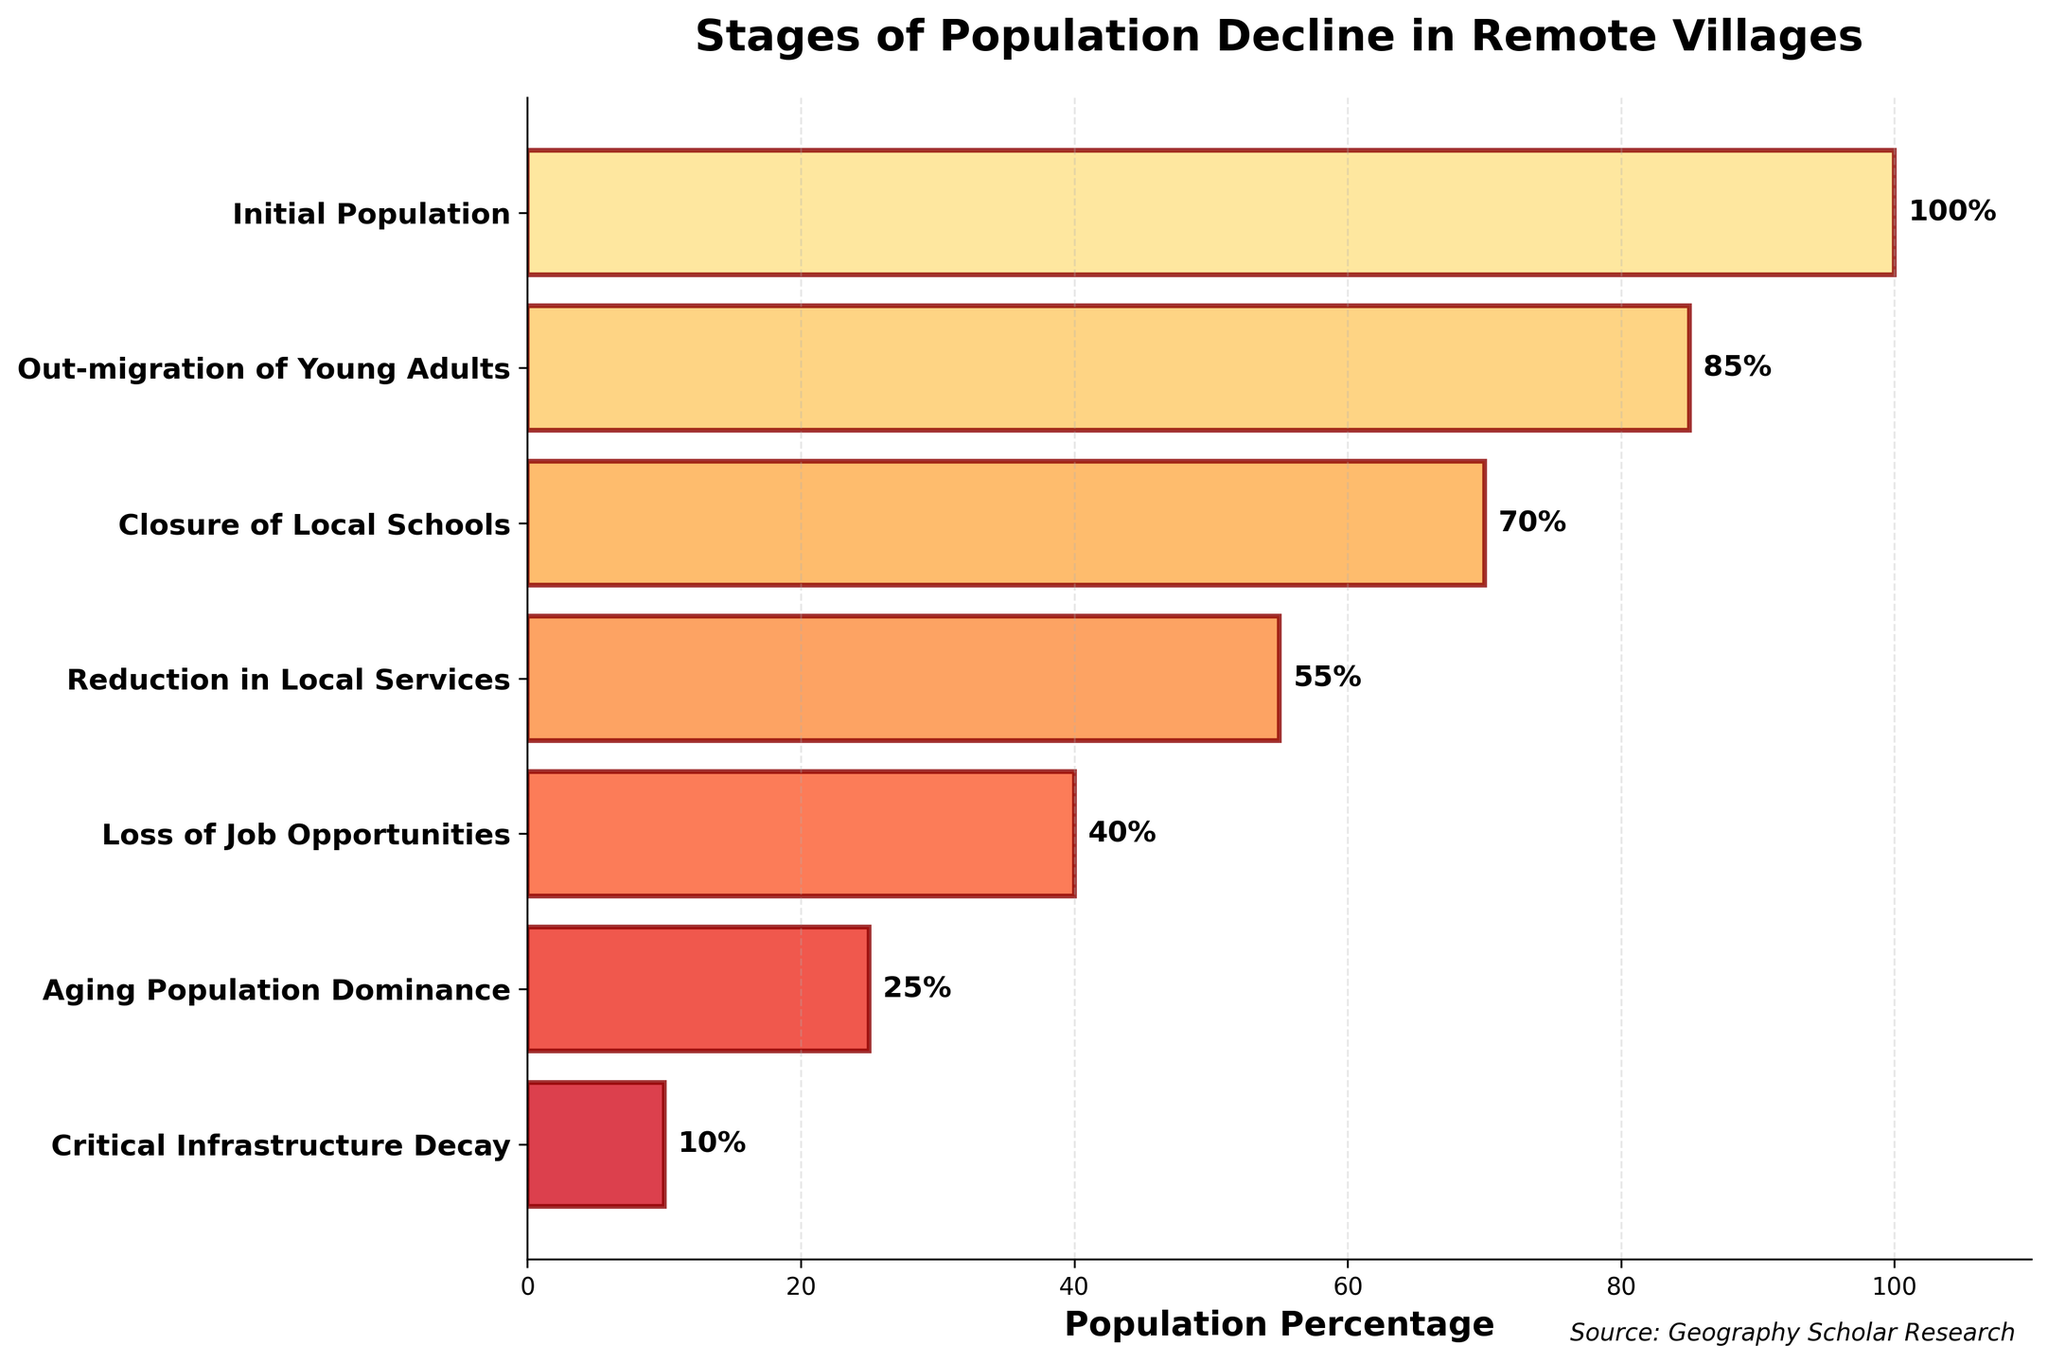What's the title of the figure? The title is usually displayed at the top of a figure and helps to provide context about the data being presented.
Answer: Stages of Population Decline in Remote Villages What's the population percentage after the "Out-migration of Young Adults" stage? The population percentage for this stage is shown directly to the right of the corresponding bar.
Answer: 85% How many stages are there in total? By counting the number of bars (or stages) from top to bottom, you can find the total number of stages.
Answer: 7 What is the difference in population percentage between the "Closure of Local Schools" stage and the "Reduction in Local Services" stage? The population percentage for "Closure of Local Schools" is 70% and for "Reduction in Local Services" is 55%. Subtracting these gives 70% - 55% = 15%.
Answer: 15% Which stage shows a drop to 40% of the initial population? By looking at the percentage labels next to each stage, it's clear that the stage with a 40% population is "Loss of Job Opportunities".
Answer: Loss of Job Opportunities Compare the population percentage at the "Initial Population" stage and the "Aging Population Dominance" stage. Which one is higher and by how much? The "Initial Population" stage is at 100%, and the "Aging Population Dominance" stage is at 25%. The difference is 100% - 25% = 75%, meaning the "Initial Population" stage is higher by 75%.
Answer: Initial Population, by 75% What stages have population percentages below 50%? By looking at the percentage labels, the stages below 50% are "Loss of Job Opportunities" (40%), "Aging Population Dominance" (25%), and "Critical Infrastructure Decay" (10%).
Answer: Loss of Job Opportunities, Aging Population Dominance, Critical Infrastructure Decay Which stage marks a population decline to less than half of the stage "Initial Population"? The "Initial Population" is 100%. Half of this is 50%. The first stage with a percentage less than 50% is "Loss of Job Opportunities".
Answer: Loss of Job Opportunities On average, by how much does the population percentage decline from one stage to the next? (Hint: Compute the average difference between consecutive stages) First, calculate the differences between each consecutive stage: (100%-85%)=15%, (85%-70%)=15%, (70%-55%)=15%, (55%-40%)=15%, (40%-25%)=15%, (25%-10%)=15%. Summing these differences gives 15%*6=90%. Divide by the number of steps (6) to find the average decline per stage: 90%/6 = 15%.
Answer: 15% What pattern does the population decline follow according to the stages? By observing the population percentages, it declines uniformly by 15% at each stage.
Answer: Uniform decline by 15% per stage 